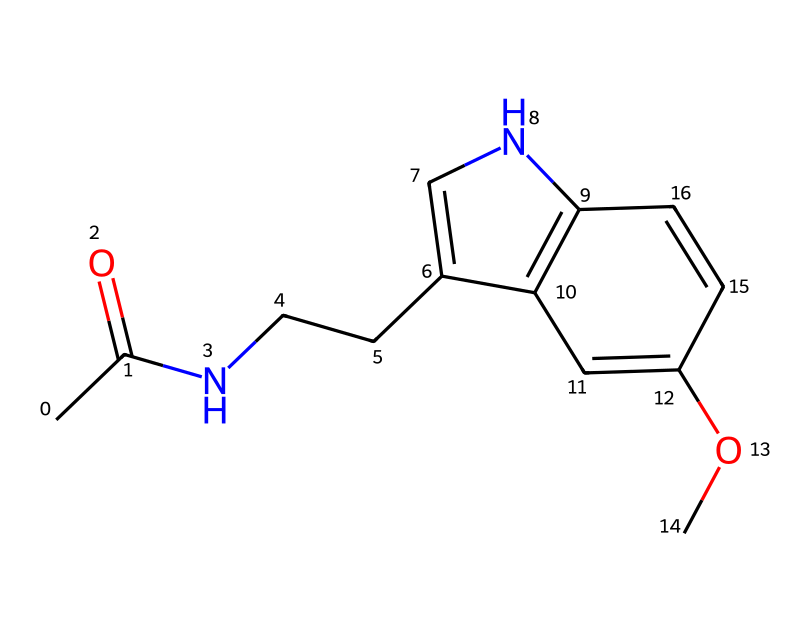What is the molecular formula of melatonin? To determine the molecular formula, we count each type of atom in the structure provided. By examining the SMILES representation, we can identify that there are 13 carbon atoms, 16 hydrogen atoms, 2 nitrogen atoms, and 2 oxygen atoms, which leads to the molecular formula C13H16N2O2.
Answer: C13H16N2O2 How many rings are present in the structure? In the visual representation of the chemical structure, we can identify that there is one nitrogen-containing ring and one fused system, making a total of two rings in melatonin's molecular structure.
Answer: 2 What functional groups are present in melatonin? By analyzing the structure, we spot two functional groups: an acetyl group (-C=O and -CH3) as seen at the beginning of the structure, and an ether group (-O-) connected to the aromatic ring, indicating the presence of functional groups related to both amides and ethers.
Answer: acetyl and ether How many double bonds does melatonin contain? Upon reviewing the structure, we can note that melatonin has two double bonds: one within the acetyl group (C=O) and one in the cyclic system involving the nitrogen atom (C=N). Therefore, the total count of double bonds in the structure is two.
Answer: 2 What is the role of melatonin in the body? Although this question goes beyond the structure itself, in the context of biochemicals, melatonin primarily functions as a hormone regulating sleep-wake cycles; its biological significance relies on this regulation through its structural properties allowing interaction with receptors.
Answer: sleep-regulating hormone 